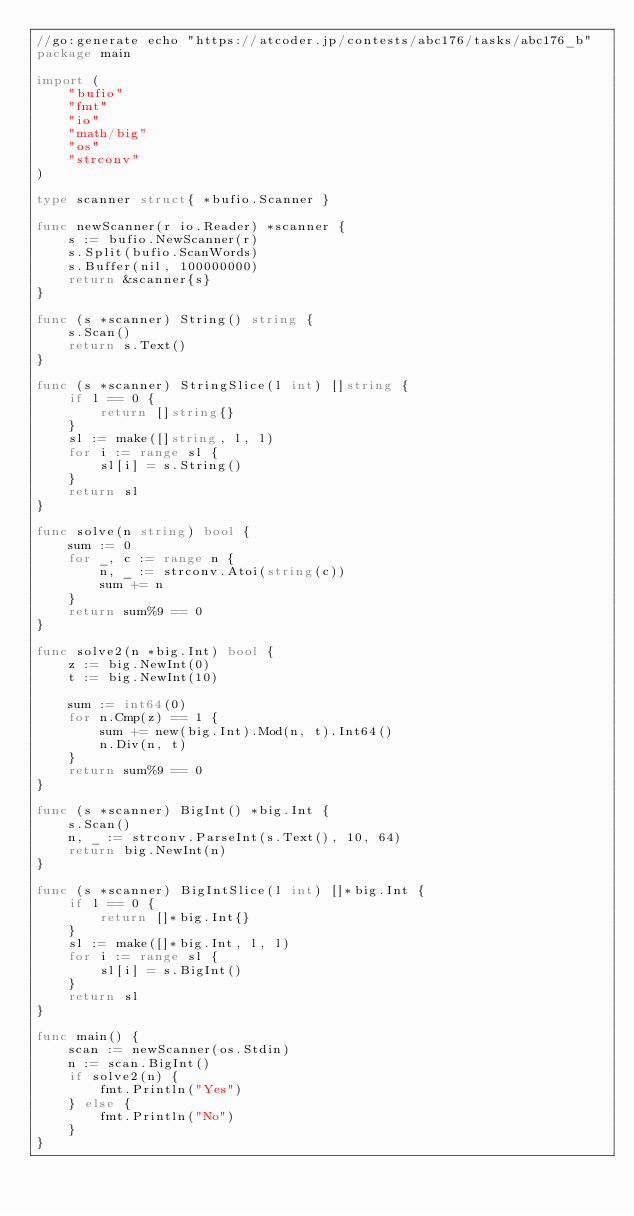Convert code to text. <code><loc_0><loc_0><loc_500><loc_500><_Go_>//go:generate echo "https://atcoder.jp/contests/abc176/tasks/abc176_b"
package main

import (
	"bufio"
	"fmt"
	"io"
	"math/big"
	"os"
	"strconv"
)

type scanner struct{ *bufio.Scanner }

func newScanner(r io.Reader) *scanner {
	s := bufio.NewScanner(r)
	s.Split(bufio.ScanWords)
	s.Buffer(nil, 100000000)
	return &scanner{s}
}

func (s *scanner) String() string {
	s.Scan()
	return s.Text()
}

func (s *scanner) StringSlice(l int) []string {
	if l == 0 {
		return []string{}
	}
	sl := make([]string, l, l)
	for i := range sl {
		sl[i] = s.String()
	}
	return sl
}

func solve(n string) bool {
	sum := 0
	for _, c := range n {
		n, _ := strconv.Atoi(string(c))
		sum += n
	}
	return sum%9 == 0
}

func solve2(n *big.Int) bool {
	z := big.NewInt(0)
	t := big.NewInt(10)

	sum := int64(0)
	for n.Cmp(z) == 1 {
		sum += new(big.Int).Mod(n, t).Int64()
		n.Div(n, t)
	}
	return sum%9 == 0
}

func (s *scanner) BigInt() *big.Int {
	s.Scan()
	n, _ := strconv.ParseInt(s.Text(), 10, 64)
	return big.NewInt(n)
}

func (s *scanner) BigIntSlice(l int) []*big.Int {
	if l == 0 {
		return []*big.Int{}
	}
	sl := make([]*big.Int, l, l)
	for i := range sl {
		sl[i] = s.BigInt()
	}
	return sl
}

func main() {
	scan := newScanner(os.Stdin)
	n := scan.BigInt()
	if solve2(n) {
		fmt.Println("Yes")
	} else {
		fmt.Println("No")
	}
}
</code> 